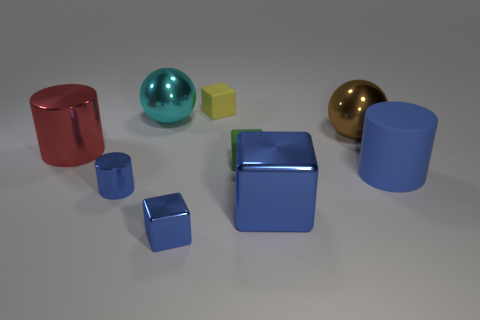Subtract all green cubes. How many cubes are left? 3 Subtract all tiny cubes. How many cubes are left? 1 Add 1 big metal balls. How many objects exist? 10 Subtract all cyan cubes. Subtract all yellow balls. How many cubes are left? 4 Subtract all balls. How many objects are left? 7 Subtract all large spheres. Subtract all cylinders. How many objects are left? 4 Add 7 blue rubber cylinders. How many blue rubber cylinders are left? 8 Add 6 cylinders. How many cylinders exist? 9 Subtract 1 red cylinders. How many objects are left? 8 